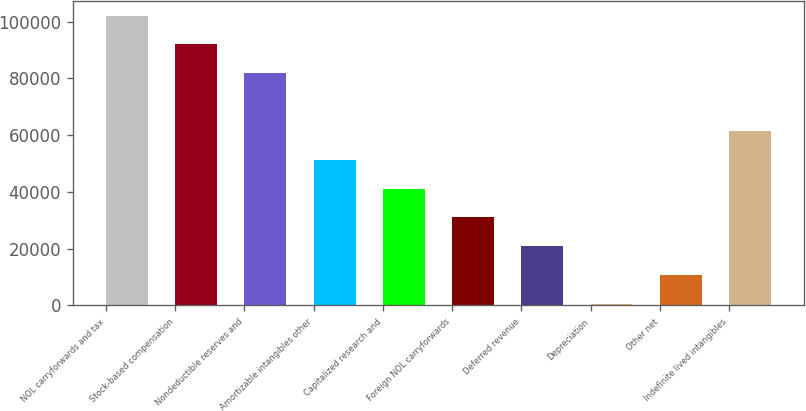Convert chart. <chart><loc_0><loc_0><loc_500><loc_500><bar_chart><fcel>NOL carryforwards and tax<fcel>Stock-based compensation<fcel>Nondeductible reserves and<fcel>Amortizable intangibles other<fcel>Capitalized research and<fcel>Foreign NOL carryforwards<fcel>Deferred revenue<fcel>Depreciation<fcel>Other net<fcel>Indefinite lived intangibles<nl><fcel>102093<fcel>91939.8<fcel>81786.6<fcel>51327<fcel>41173.8<fcel>31020.6<fcel>20867.4<fcel>561<fcel>10714.2<fcel>61480.2<nl></chart> 